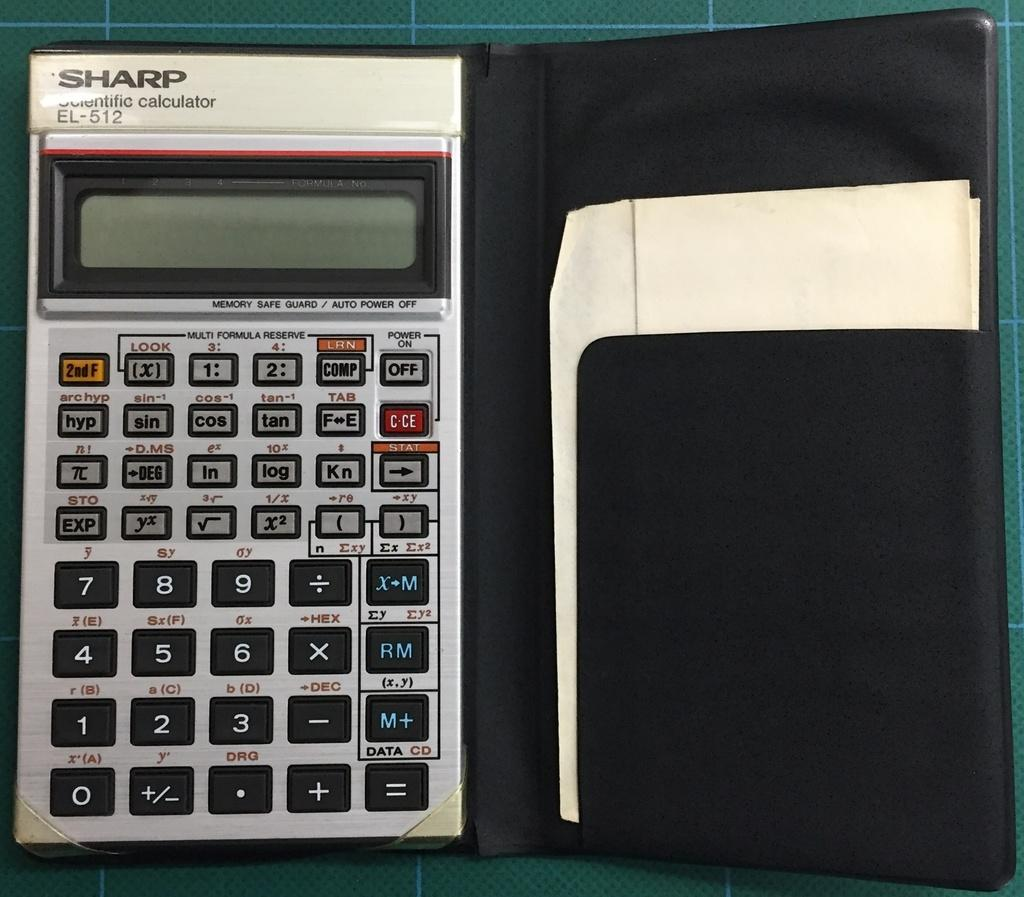<image>
Share a concise interpretation of the image provided. A Sharp scientific calculator in a black case 